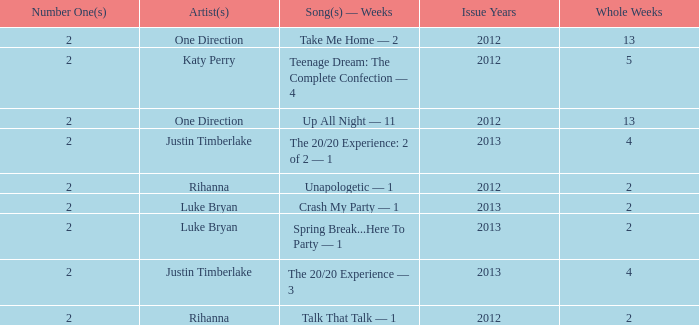What is the longest number of weeks any 1 song was at number #1? 13.0. 